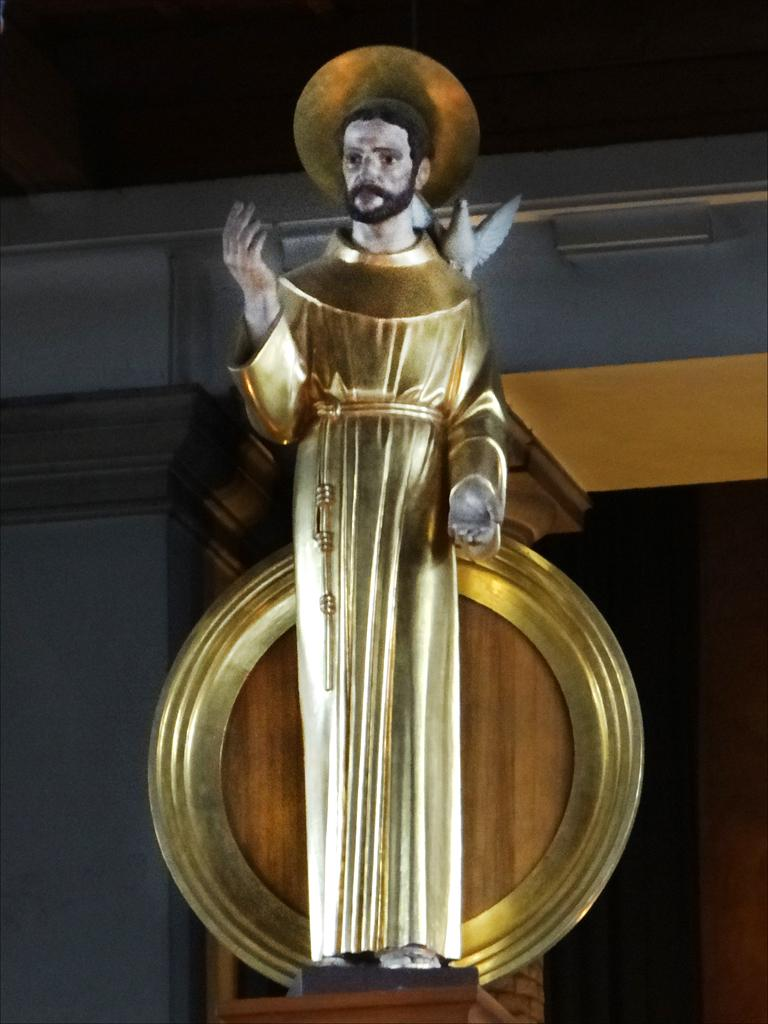What type of sculpture can be seen in the image? There is a sculpture of a man and a sculpture of a bird in the image. What color is the sculpture of the man? The sculpture of the man is in golden color. What color is the sculpture of the bird? The sculpture of the bird is in white color. What type of twig can be seen in the image? There is no twig present in the image; it features two sculptures, one of a man and one of a bird. Is there any writing visible on the sculptures in the image? There is no writing visible on the sculptures in the image. 